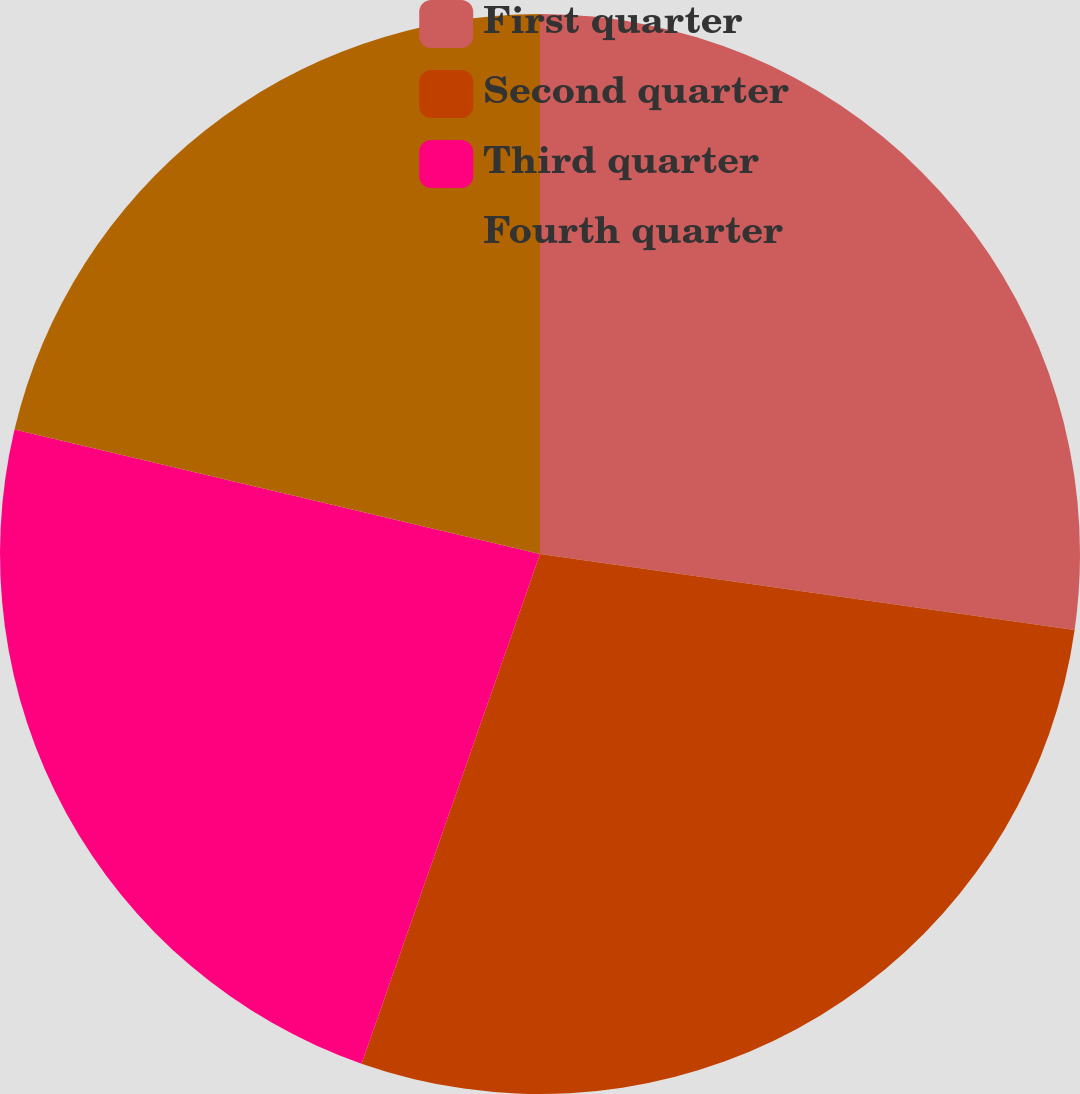Convert chart to OTSL. <chart><loc_0><loc_0><loc_500><loc_500><pie_chart><fcel>First quarter<fcel>Second quarter<fcel>Third quarter<fcel>Fourth quarter<nl><fcel>27.25%<fcel>28.11%<fcel>23.34%<fcel>21.3%<nl></chart> 